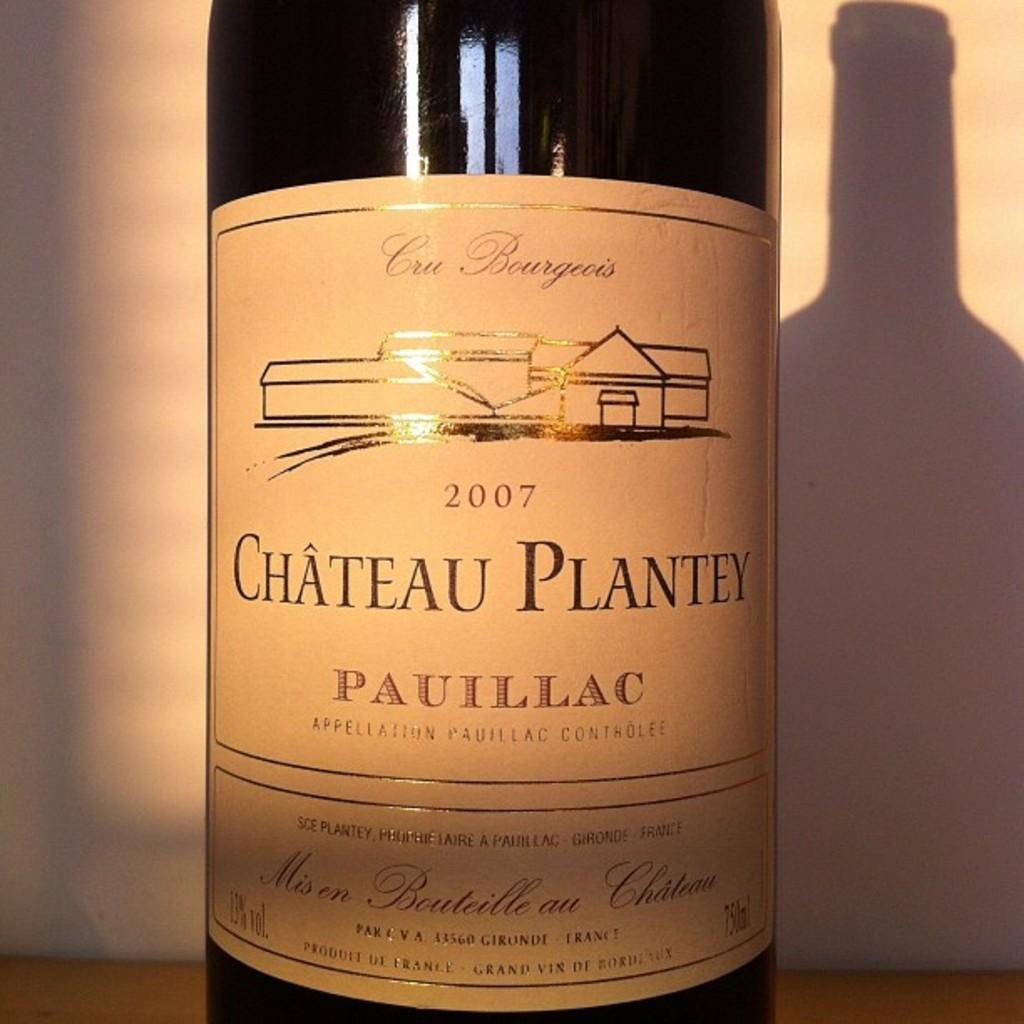Provide a one-sentence caption for the provided image. A bottle of wine from Chateau Plantey from 2007. 